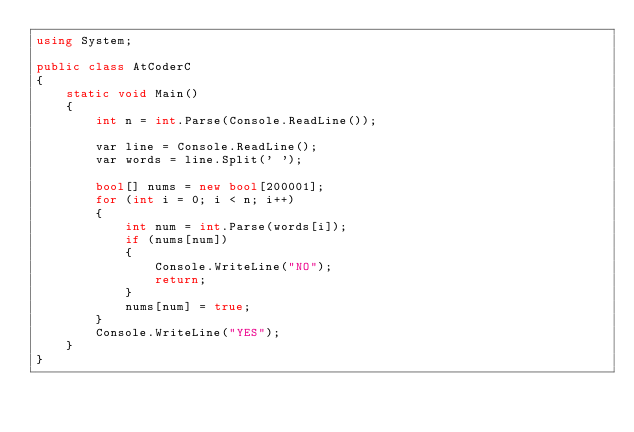<code> <loc_0><loc_0><loc_500><loc_500><_C#_>using System;

public class AtCoderC
{
    static void Main()
    {
        int n = int.Parse(Console.ReadLine());

        var line = Console.ReadLine();
        var words = line.Split(' ');

        bool[] nums = new bool[200001];
        for (int i = 0; i < n; i++)
        {
            int num = int.Parse(words[i]);
            if (nums[num])
            {
                Console.WriteLine("NO");
                return;
            }
            nums[num] = true;
        }
        Console.WriteLine("YES");
    }
}</code> 